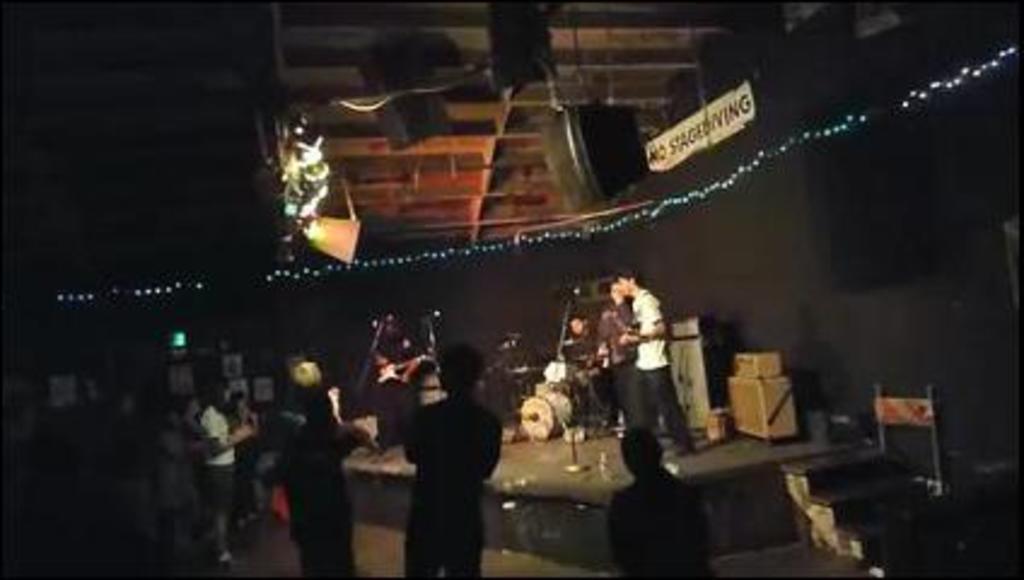How would you summarize this image in a sentence or two? In the picture people standing on the floor. I can also see musical instruments, string lights, a board which has something written on it and some other objects. This image is little bit dark. 